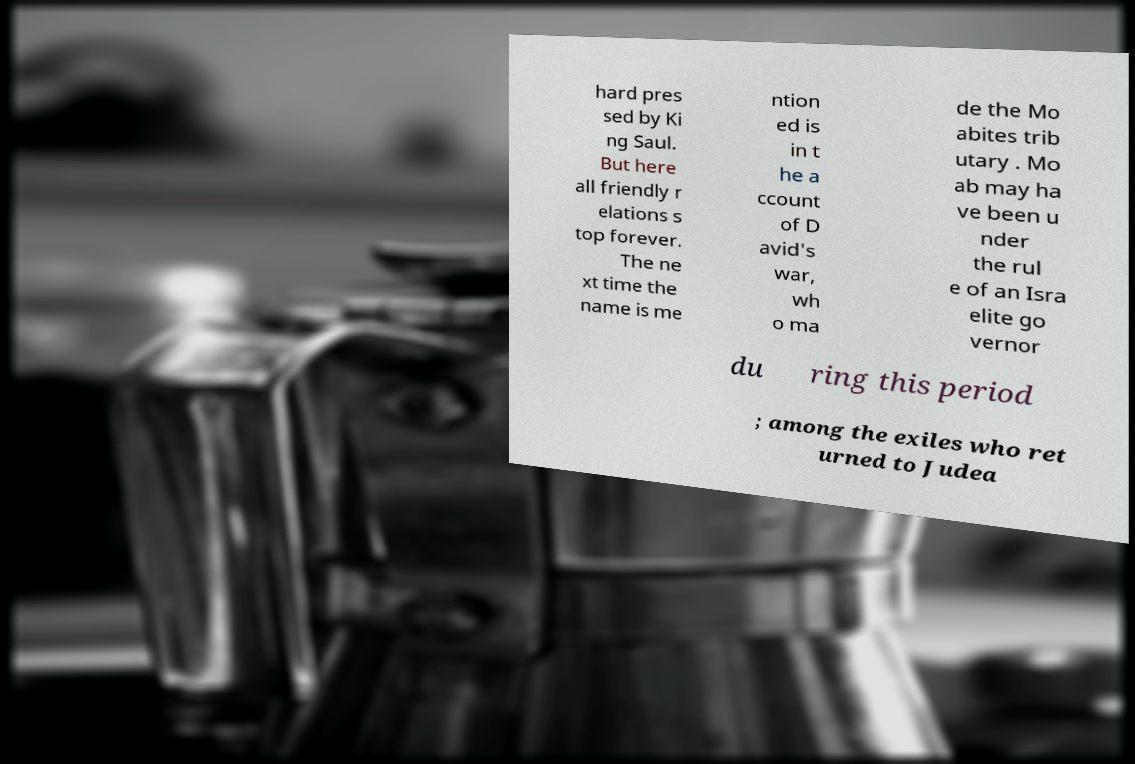Could you extract and type out the text from this image? hard pres sed by Ki ng Saul. But here all friendly r elations s top forever. The ne xt time the name is me ntion ed is in t he a ccount of D avid's war, wh o ma de the Mo abites trib utary . Mo ab may ha ve been u nder the rul e of an Isra elite go vernor du ring this period ; among the exiles who ret urned to Judea 